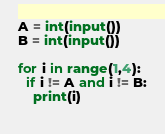<code> <loc_0><loc_0><loc_500><loc_500><_Python_>A = int(input())
B = int(input())

for i in range(1,4):
  if i != A and i != B:
    print(i)
  </code> 